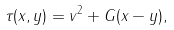Convert formula to latex. <formula><loc_0><loc_0><loc_500><loc_500>\tau ( x , y ) = v ^ { 2 } + G ( x - y ) ,</formula> 